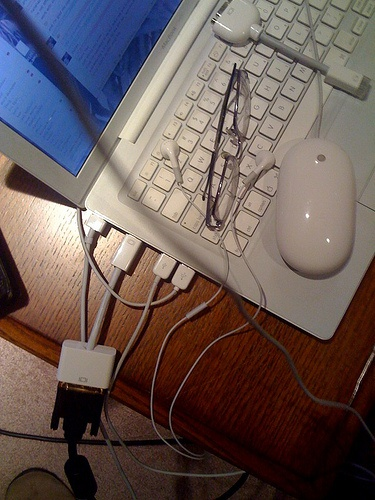Describe the objects in this image and their specific colors. I can see laptop in navy, darkgray, and gray tones, keyboard in navy, darkgray, gray, and tan tones, and mouse in navy, darkgray, and gray tones in this image. 